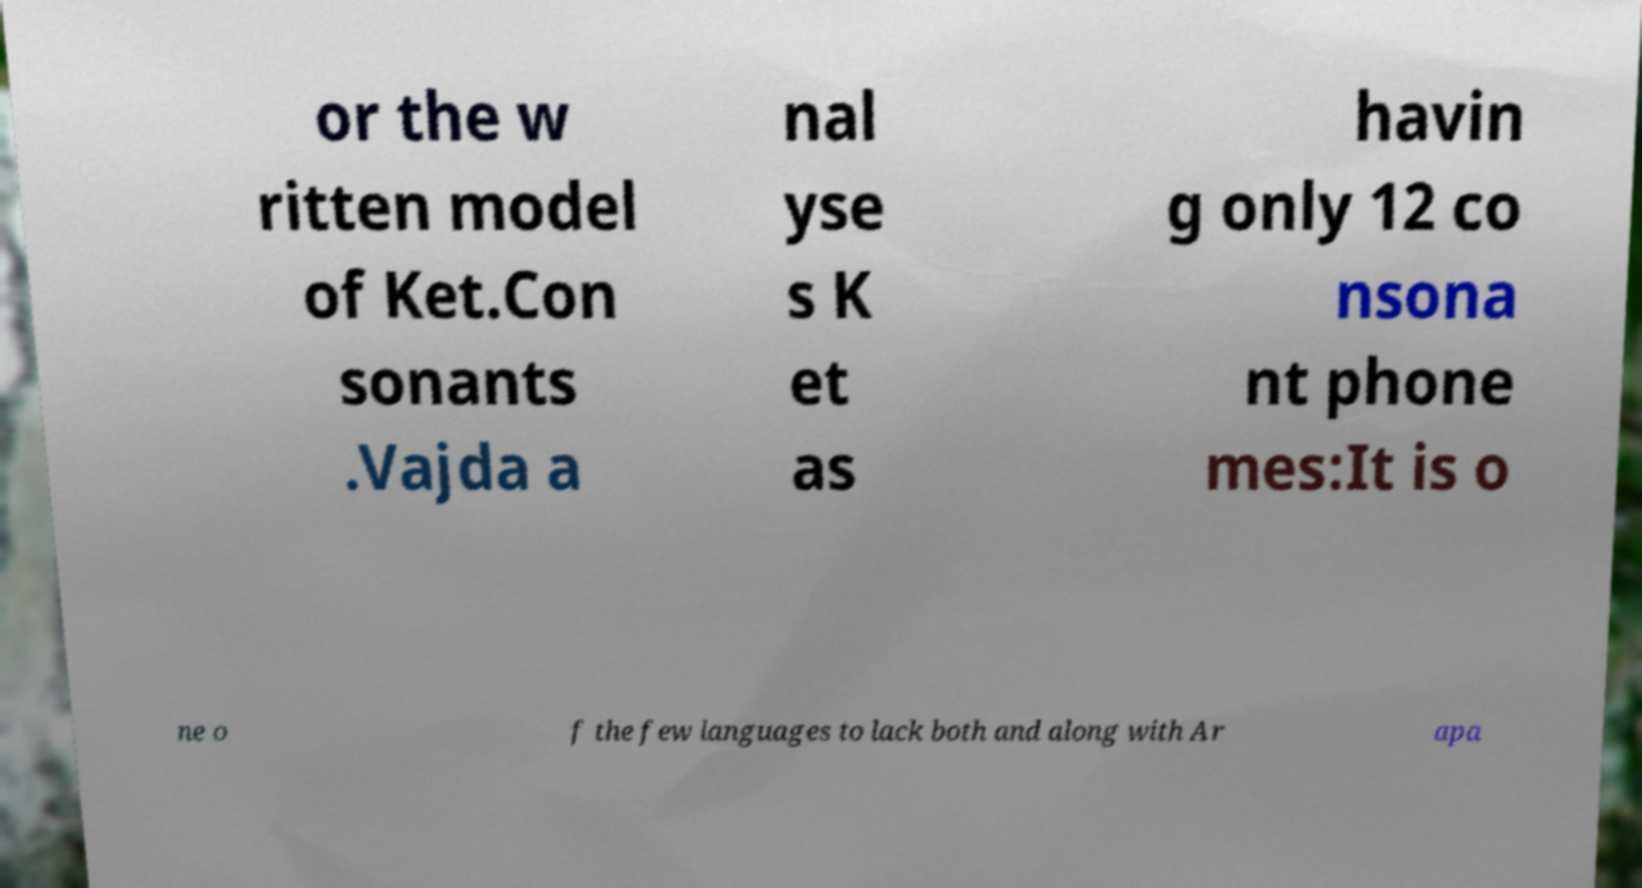There's text embedded in this image that I need extracted. Can you transcribe it verbatim? or the w ritten model of Ket.Con sonants .Vajda a nal yse s K et as havin g only 12 co nsona nt phone mes:It is o ne o f the few languages to lack both and along with Ar apa 